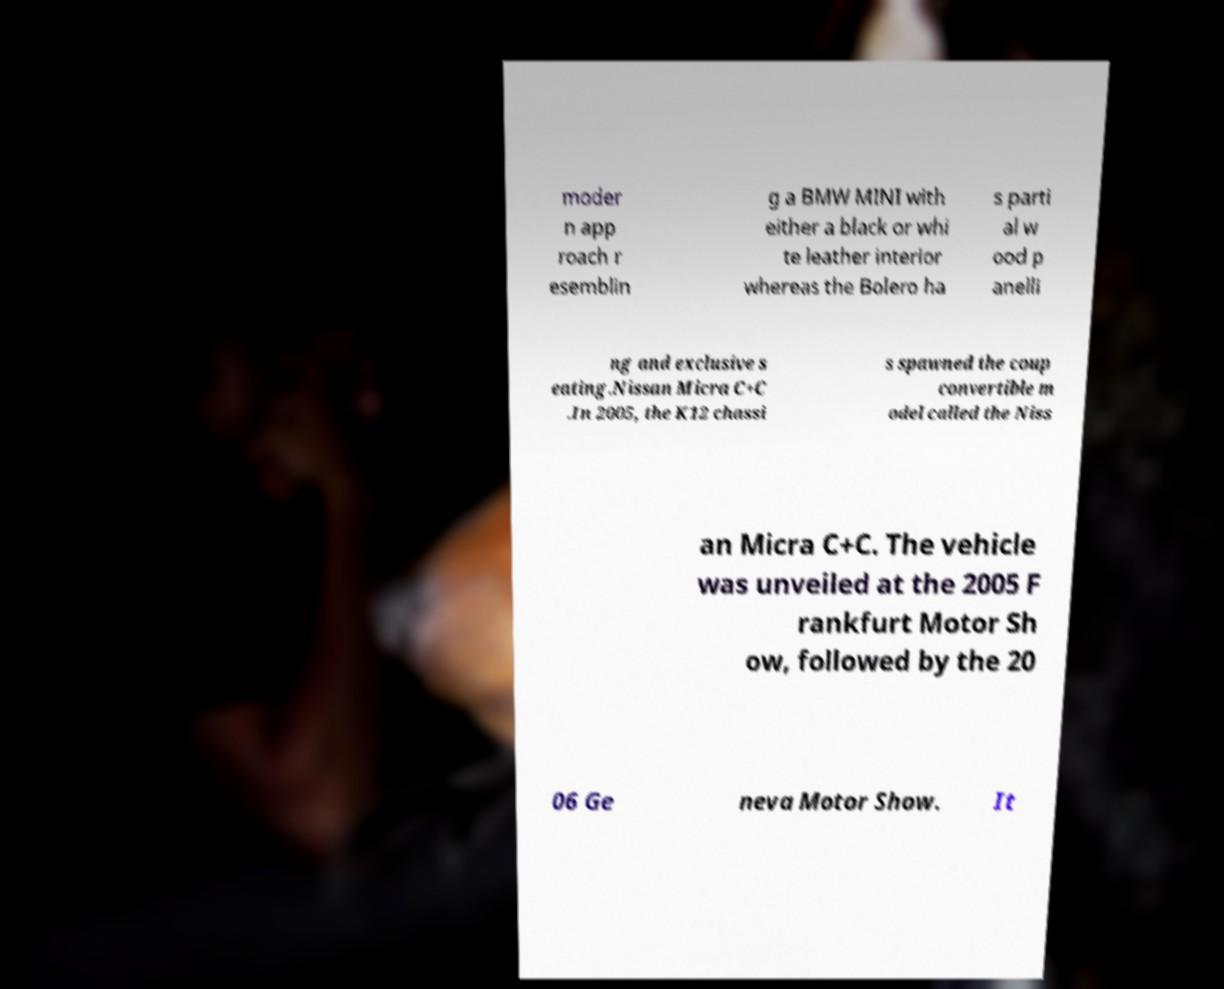Please read and relay the text visible in this image. What does it say? moder n app roach r esemblin g a BMW MINI with either a black or whi te leather interior whereas the Bolero ha s parti al w ood p anelli ng and exclusive s eating.Nissan Micra C+C .In 2005, the K12 chassi s spawned the coup convertible m odel called the Niss an Micra C+C. The vehicle was unveiled at the 2005 F rankfurt Motor Sh ow, followed by the 20 06 Ge neva Motor Show. It 